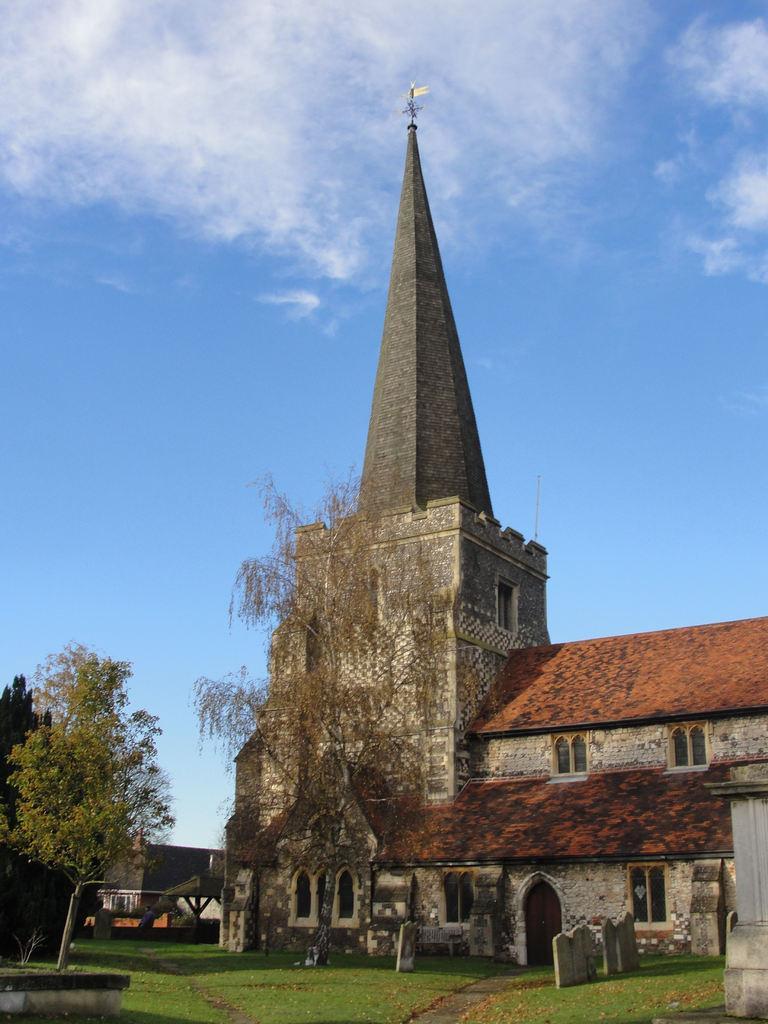In one or two sentences, can you explain what this image depicts? In this picture we can see grass, few headstones, trees, buildings and clouds. 